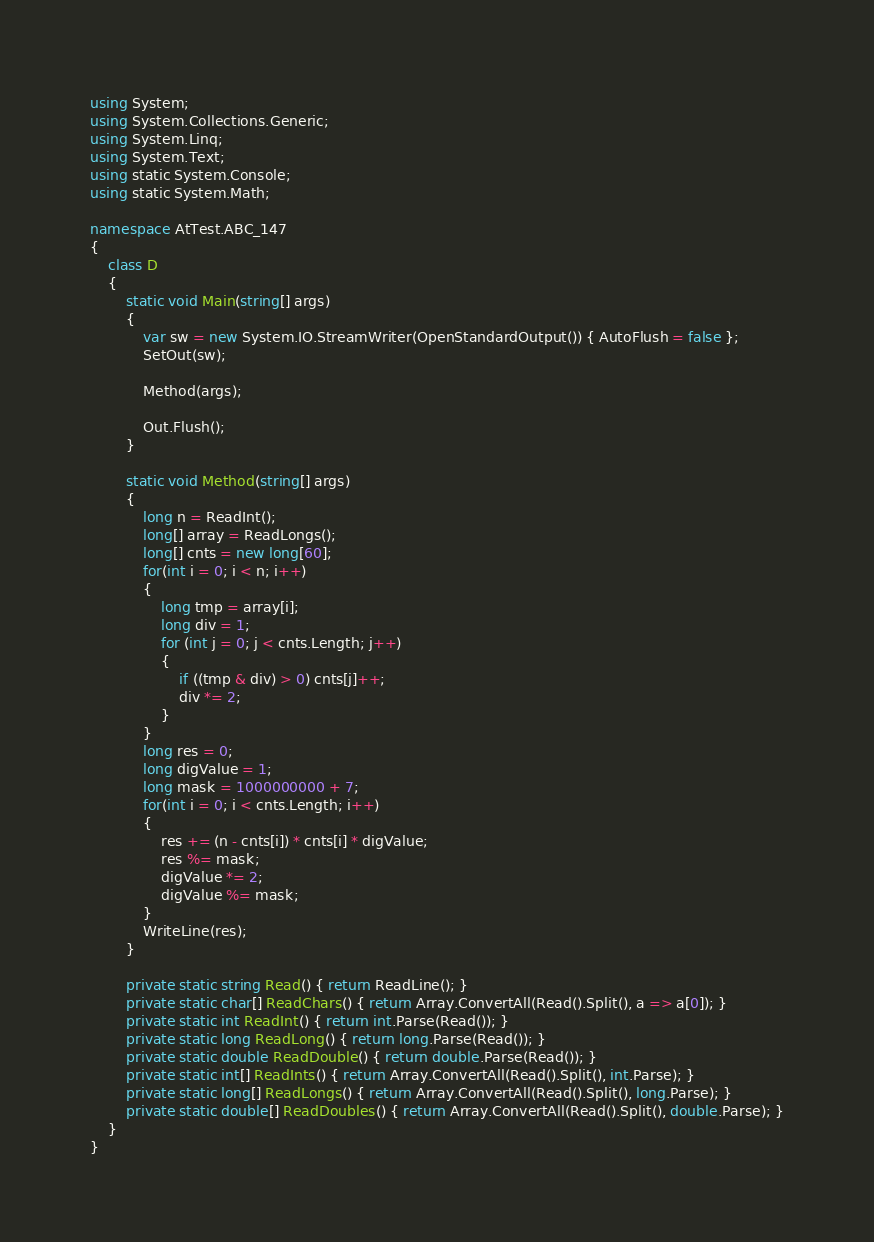Convert code to text. <code><loc_0><loc_0><loc_500><loc_500><_C#_>using System;
using System.Collections.Generic;
using System.Linq;
using System.Text;
using static System.Console;
using static System.Math;

namespace AtTest.ABC_147
{
    class D
    {
        static void Main(string[] args)
        {
            var sw = new System.IO.StreamWriter(OpenStandardOutput()) { AutoFlush = false };
            SetOut(sw);

            Method(args);

            Out.Flush();
        }

        static void Method(string[] args)
        {
            long n = ReadInt();
            long[] array = ReadLongs();
            long[] cnts = new long[60];
            for(int i = 0; i < n; i++)
            {
                long tmp = array[i];
                long div = 1;
                for (int j = 0; j < cnts.Length; j++)
                {
                    if ((tmp & div) > 0) cnts[j]++;
                    div *= 2;
                }
            }
            long res = 0;
            long digValue = 1;
            long mask = 1000000000 + 7;
            for(int i = 0; i < cnts.Length; i++)
            {
                res += (n - cnts[i]) * cnts[i] * digValue;
                res %= mask;
                digValue *= 2;
                digValue %= mask;
            }
            WriteLine(res);
        }

        private static string Read() { return ReadLine(); }
        private static char[] ReadChars() { return Array.ConvertAll(Read().Split(), a => a[0]); }
        private static int ReadInt() { return int.Parse(Read()); }
        private static long ReadLong() { return long.Parse(Read()); }
        private static double ReadDouble() { return double.Parse(Read()); }
        private static int[] ReadInts() { return Array.ConvertAll(Read().Split(), int.Parse); }
        private static long[] ReadLongs() { return Array.ConvertAll(Read().Split(), long.Parse); }
        private static double[] ReadDoubles() { return Array.ConvertAll(Read().Split(), double.Parse); }
    }
}
</code> 